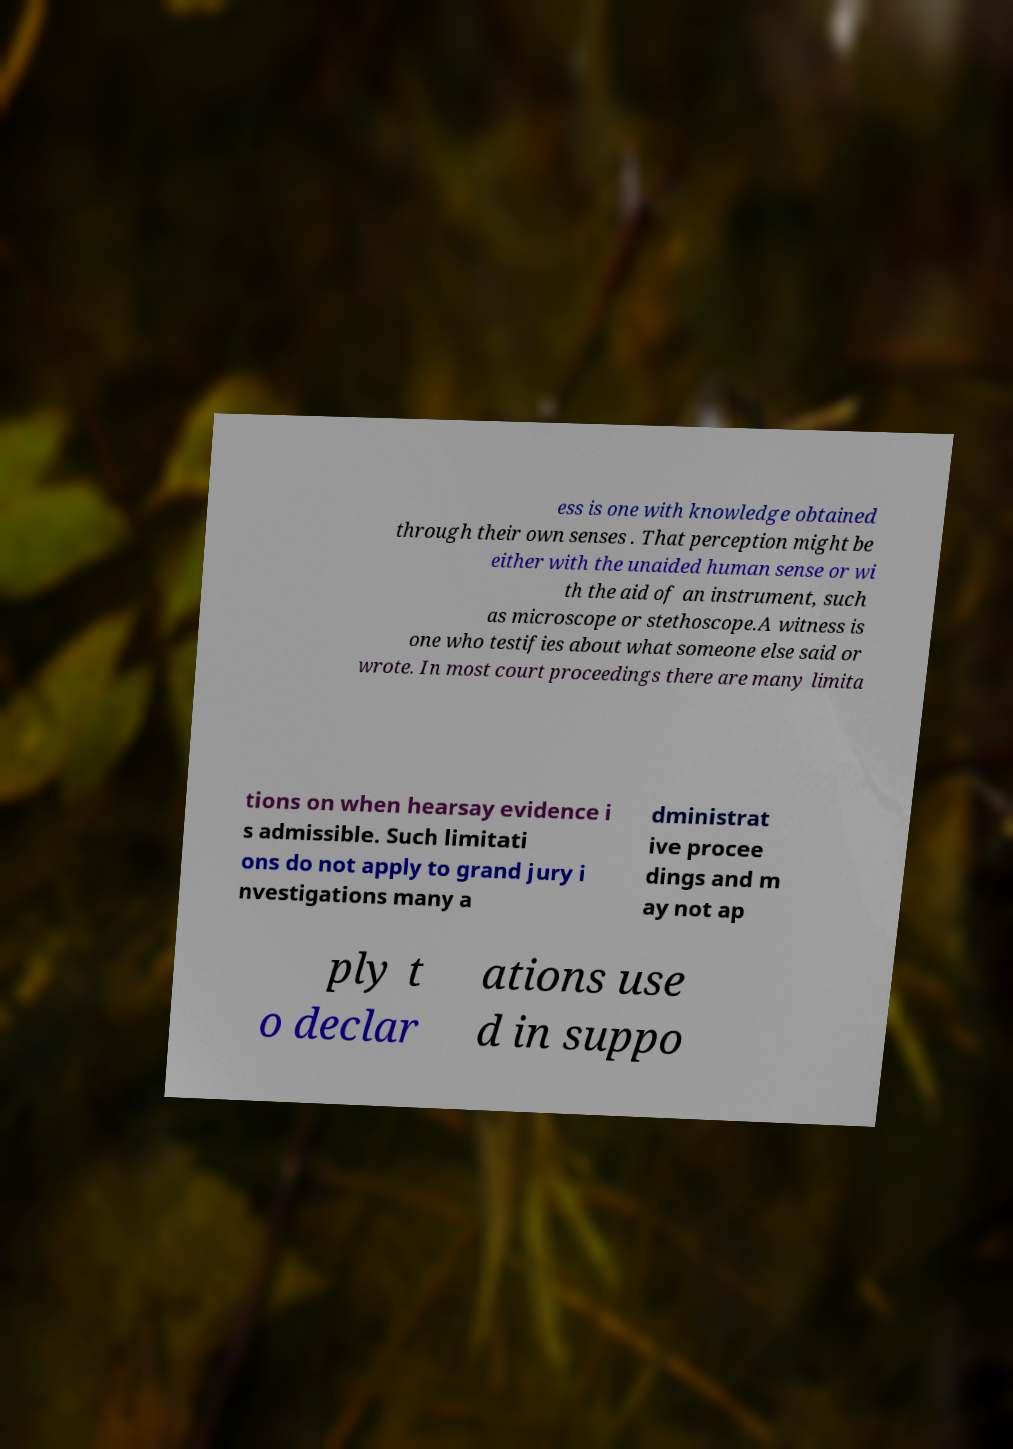What messages or text are displayed in this image? I need them in a readable, typed format. ess is one with knowledge obtained through their own senses . That perception might be either with the unaided human sense or wi th the aid of an instrument, such as microscope or stethoscope.A witness is one who testifies about what someone else said or wrote. In most court proceedings there are many limita tions on when hearsay evidence i s admissible. Such limitati ons do not apply to grand jury i nvestigations many a dministrat ive procee dings and m ay not ap ply t o declar ations use d in suppo 